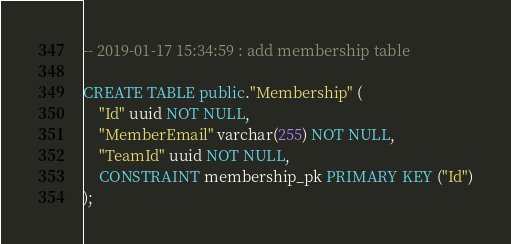<code> <loc_0><loc_0><loc_500><loc_500><_SQL_>-- 2019-01-17 15:34:59 : add membership table

CREATE TABLE public."Membership" (
    "Id" uuid NOT NULL,
    "MemberEmail" varchar(255) NOT NULL,
    "TeamId" uuid NOT NULL,
    CONSTRAINT membership_pk PRIMARY KEY ("Id")
);
</code> 